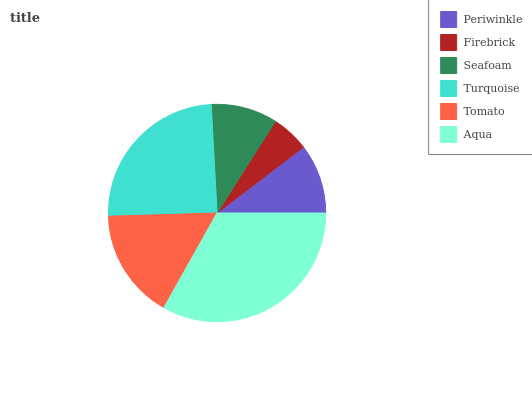Is Firebrick the minimum?
Answer yes or no. Yes. Is Aqua the maximum?
Answer yes or no. Yes. Is Seafoam the minimum?
Answer yes or no. No. Is Seafoam the maximum?
Answer yes or no. No. Is Seafoam greater than Firebrick?
Answer yes or no. Yes. Is Firebrick less than Seafoam?
Answer yes or no. Yes. Is Firebrick greater than Seafoam?
Answer yes or no. No. Is Seafoam less than Firebrick?
Answer yes or no. No. Is Tomato the high median?
Answer yes or no. Yes. Is Periwinkle the low median?
Answer yes or no. Yes. Is Firebrick the high median?
Answer yes or no. No. Is Tomato the low median?
Answer yes or no. No. 